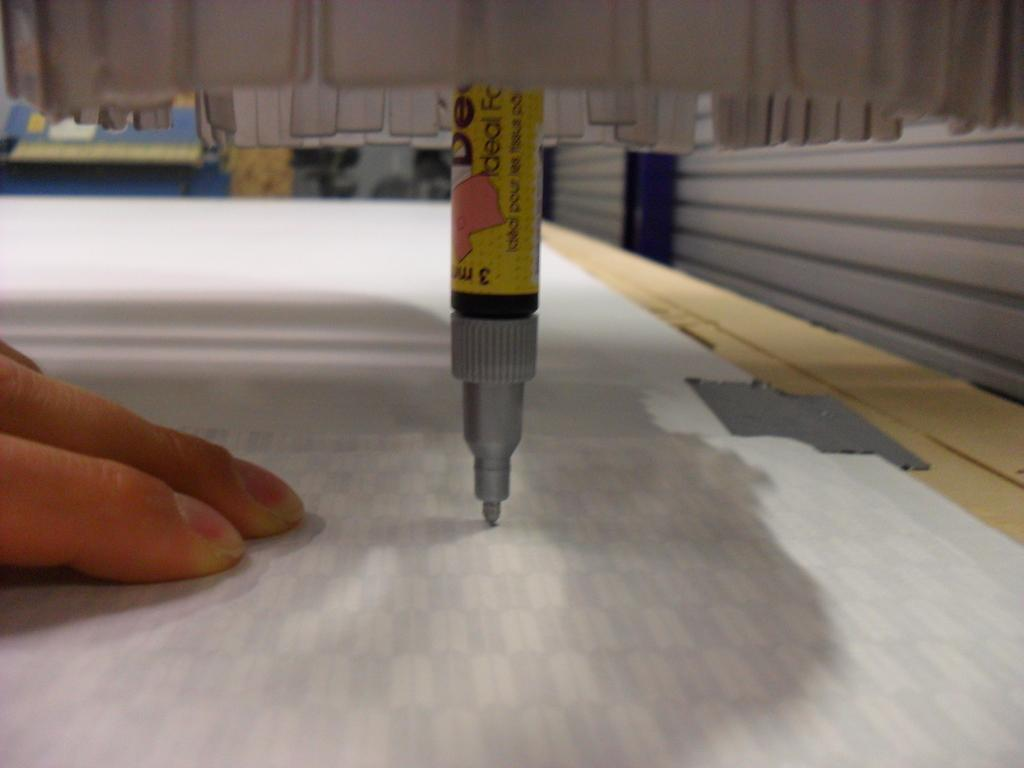<image>
Summarize the visual content of the image. A pen that says ideal being held straight up over some paper next to a hand. 